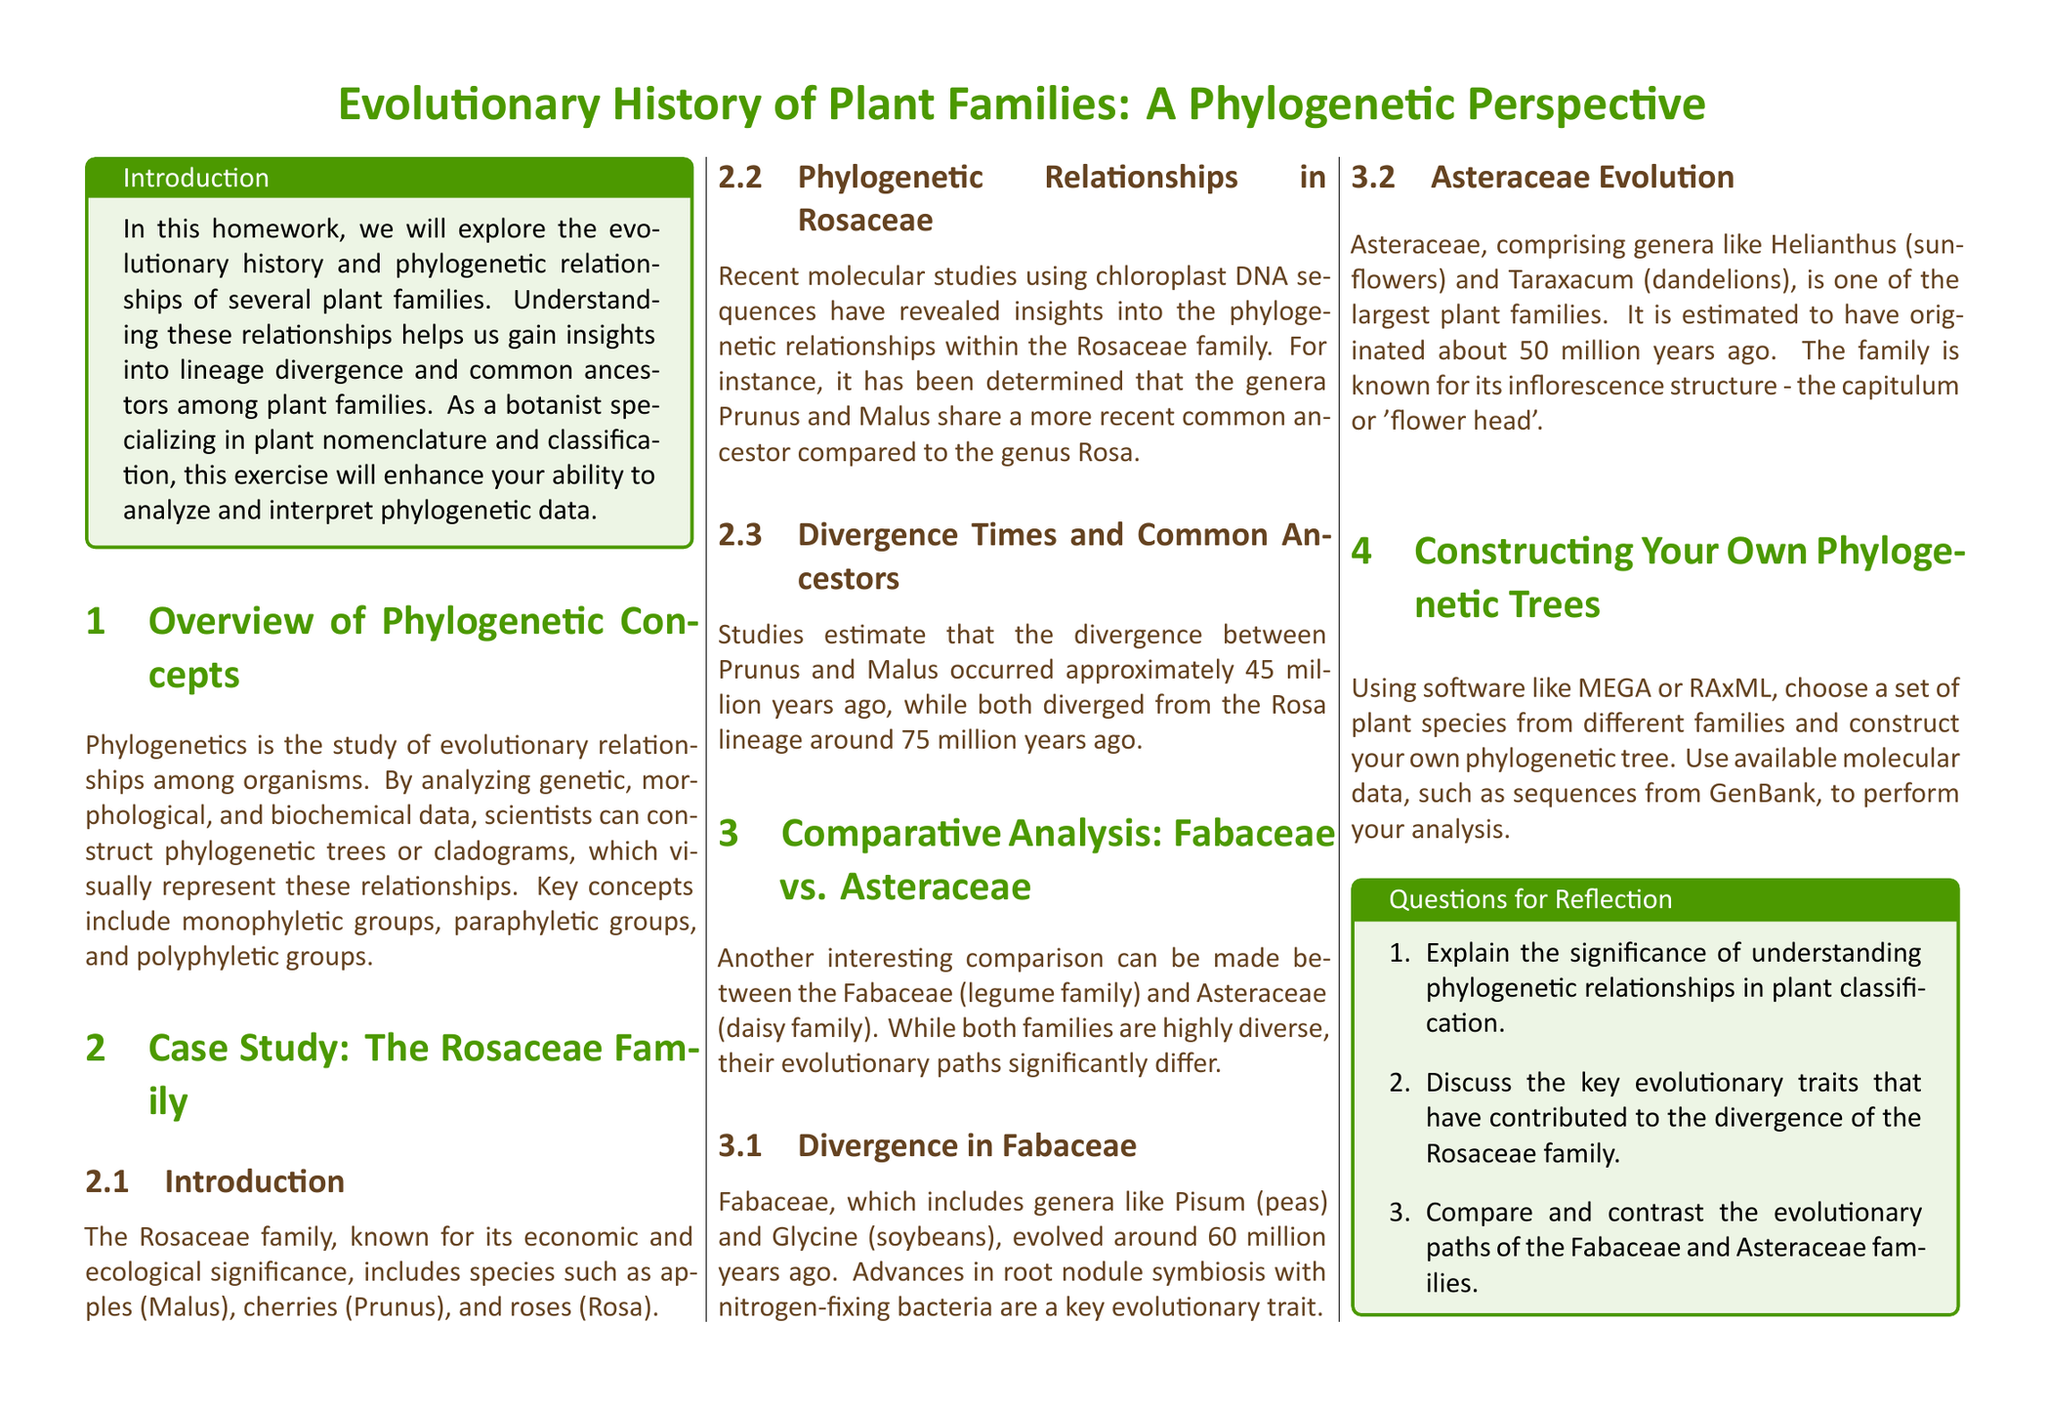What is the focus of this homework? The homework focuses on exploring the evolutionary history and phylogenetic relationships of plant families.
Answer: evolutionary history and phylogenetic relationships of plant families Which family includes apples and cherries? The Rosaceae family includes species such as apples (Malus) and cherries (Prunus).
Answer: Rosaceae How many million years ago did Prunus and Malus diverge? Studies estimate that the divergence between Prunus and Malus occurred approximately 45 million years ago.
Answer: 45 million years What significant evolutionary trait is associated with the Fabaceae family? Advances in root nodule symbiosis with nitrogen-fixing bacteria are a key evolutionary trait of the Fabaceae family.
Answer: root nodule symbiosis Which plant family is estimated to have originated about 50 million years ago? The Asteraceae family is estimated to have originated about 50 million years ago.
Answer: Asteraceae What is the purpose of constructing phylogenetic trees in this homework? The purpose is to analyze and visualize the evolutionary relationships among different plant species.
Answer: analyze and visualize relationships Which software is suggested for constructing phylogenetic trees? MEGA or RAxML are suggested software for constructing phylogenetic trees.
Answer: MEGA or RAxML What type of groups are key concepts in phylogenetics? Monophyletic groups, paraphyletic groups, and polyphyletic groups are key concepts in phylogenetics.
Answer: Monophyletic, paraphyletic, polyphyletic What two families are compared in the document? The document compares the Fabaceae family and the Asteraceae family.
Answer: Fabaceae and Asteraceae 